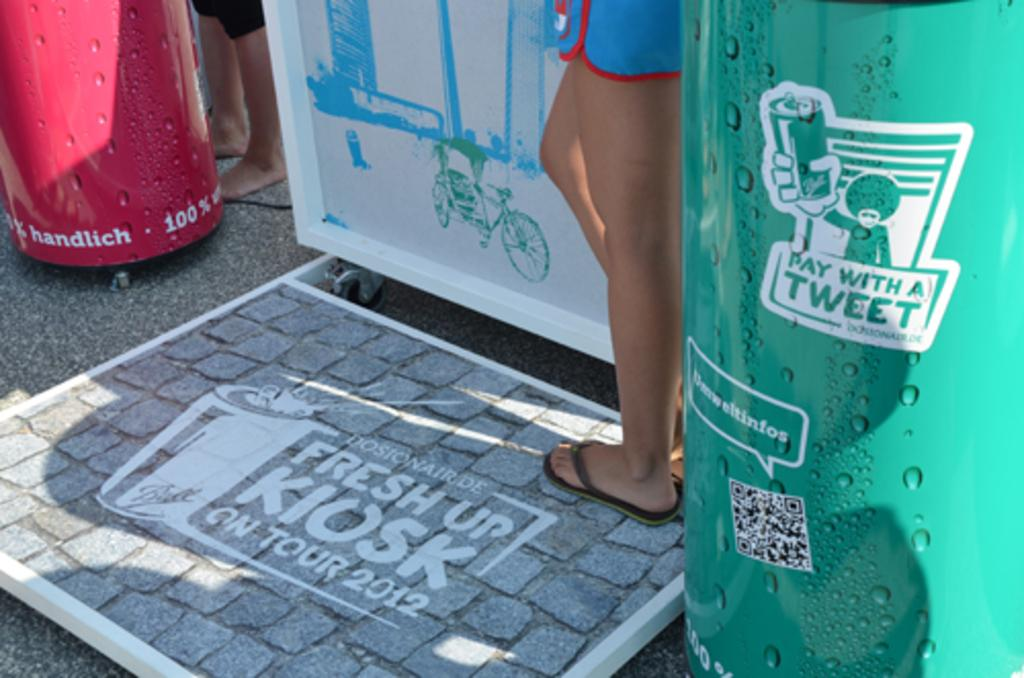What is the main subject of the image? There is a person standing in the image. Can you describe the surface the person is standing on? The person is standing on a surface. What is underneath the surface? There is a floor below the surface. What else can be seen on the surface? There are tins with legs on either side of the surface. What type of health advice is the person giving in the image? There is no indication in the image that the person is giving health advice or any advice at all. 